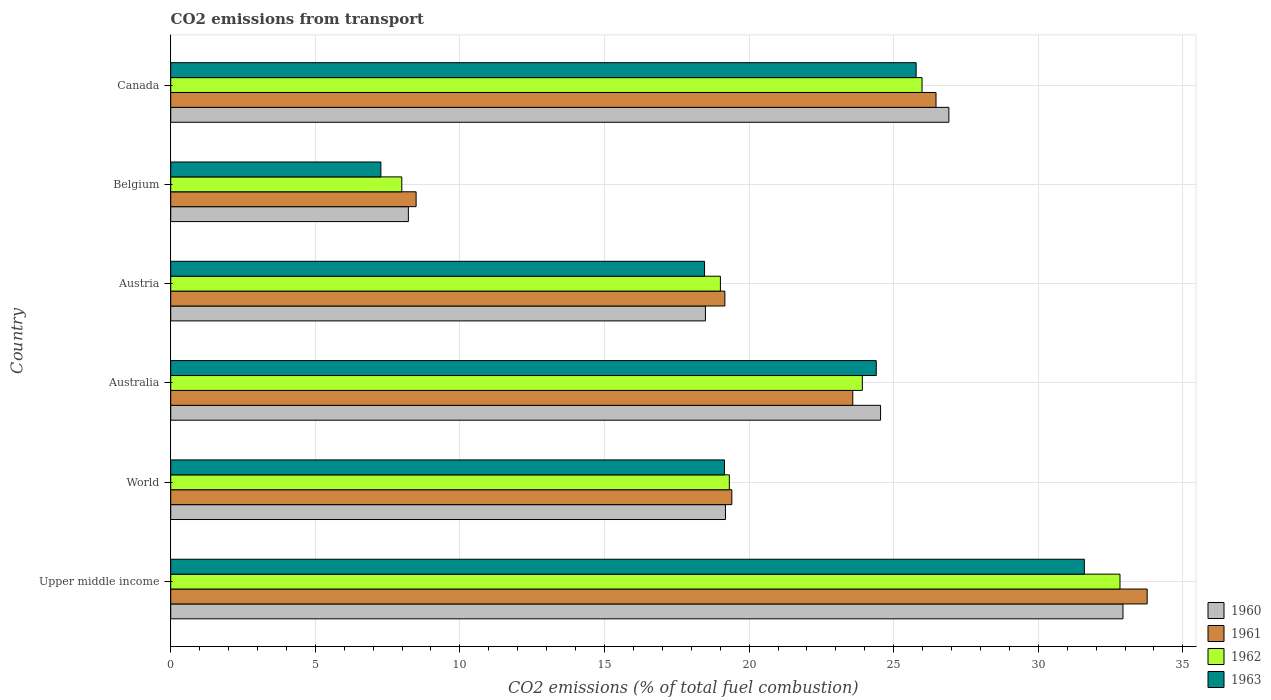Are the number of bars per tick equal to the number of legend labels?
Your response must be concise. Yes. Are the number of bars on each tick of the Y-axis equal?
Ensure brevity in your answer.  Yes. What is the label of the 4th group of bars from the top?
Give a very brief answer. Australia. What is the total CO2 emitted in 1962 in Belgium?
Keep it short and to the point. 7.99. Across all countries, what is the maximum total CO2 emitted in 1963?
Offer a very short reply. 31.59. Across all countries, what is the minimum total CO2 emitted in 1960?
Keep it short and to the point. 8.22. In which country was the total CO2 emitted in 1963 maximum?
Make the answer very short. Upper middle income. In which country was the total CO2 emitted in 1963 minimum?
Keep it short and to the point. Belgium. What is the total total CO2 emitted in 1961 in the graph?
Offer a very short reply. 130.86. What is the difference between the total CO2 emitted in 1962 in Austria and that in Canada?
Provide a short and direct response. -6.97. What is the difference between the total CO2 emitted in 1962 in Australia and the total CO2 emitted in 1961 in World?
Make the answer very short. 4.51. What is the average total CO2 emitted in 1961 per country?
Your answer should be compact. 21.81. What is the difference between the total CO2 emitted in 1963 and total CO2 emitted in 1962 in Austria?
Offer a very short reply. -0.55. In how many countries, is the total CO2 emitted in 1963 greater than 32 ?
Offer a very short reply. 0. What is the ratio of the total CO2 emitted in 1962 in Australia to that in Canada?
Offer a terse response. 0.92. Is the total CO2 emitted in 1962 in Upper middle income less than that in World?
Your response must be concise. No. What is the difference between the highest and the second highest total CO2 emitted in 1962?
Your answer should be very brief. 6.84. What is the difference between the highest and the lowest total CO2 emitted in 1961?
Offer a very short reply. 25.28. In how many countries, is the total CO2 emitted in 1962 greater than the average total CO2 emitted in 1962 taken over all countries?
Provide a short and direct response. 3. What does the 4th bar from the top in Upper middle income represents?
Provide a succinct answer. 1960. What does the 1st bar from the bottom in Australia represents?
Provide a succinct answer. 1960. How many bars are there?
Your answer should be very brief. 24. How many countries are there in the graph?
Ensure brevity in your answer.  6. Does the graph contain grids?
Provide a short and direct response. Yes. Where does the legend appear in the graph?
Your answer should be compact. Bottom right. How many legend labels are there?
Offer a very short reply. 4. What is the title of the graph?
Your response must be concise. CO2 emissions from transport. What is the label or title of the X-axis?
Give a very brief answer. CO2 emissions (% of total fuel combustion). What is the CO2 emissions (% of total fuel combustion) in 1960 in Upper middle income?
Provide a succinct answer. 32.93. What is the CO2 emissions (% of total fuel combustion) of 1961 in Upper middle income?
Your answer should be compact. 33.76. What is the CO2 emissions (% of total fuel combustion) in 1962 in Upper middle income?
Keep it short and to the point. 32.82. What is the CO2 emissions (% of total fuel combustion) of 1963 in Upper middle income?
Keep it short and to the point. 31.59. What is the CO2 emissions (% of total fuel combustion) in 1960 in World?
Your answer should be very brief. 19.18. What is the CO2 emissions (% of total fuel combustion) in 1961 in World?
Keep it short and to the point. 19.4. What is the CO2 emissions (% of total fuel combustion) of 1962 in World?
Ensure brevity in your answer.  19.32. What is the CO2 emissions (% of total fuel combustion) in 1963 in World?
Provide a short and direct response. 19.15. What is the CO2 emissions (% of total fuel combustion) of 1960 in Australia?
Provide a succinct answer. 24.55. What is the CO2 emissions (% of total fuel combustion) in 1961 in Australia?
Provide a short and direct response. 23.59. What is the CO2 emissions (% of total fuel combustion) of 1962 in Australia?
Your response must be concise. 23.92. What is the CO2 emissions (% of total fuel combustion) in 1963 in Australia?
Offer a very short reply. 24.4. What is the CO2 emissions (% of total fuel combustion) of 1960 in Austria?
Your response must be concise. 18.49. What is the CO2 emissions (% of total fuel combustion) in 1961 in Austria?
Your answer should be compact. 19.16. What is the CO2 emissions (% of total fuel combustion) in 1962 in Austria?
Ensure brevity in your answer.  19.01. What is the CO2 emissions (% of total fuel combustion) in 1963 in Austria?
Your answer should be very brief. 18.46. What is the CO2 emissions (% of total fuel combustion) of 1960 in Belgium?
Give a very brief answer. 8.22. What is the CO2 emissions (% of total fuel combustion) of 1961 in Belgium?
Give a very brief answer. 8.49. What is the CO2 emissions (% of total fuel combustion) of 1962 in Belgium?
Your answer should be compact. 7.99. What is the CO2 emissions (% of total fuel combustion) in 1963 in Belgium?
Ensure brevity in your answer.  7.27. What is the CO2 emissions (% of total fuel combustion) of 1960 in Canada?
Make the answer very short. 26.91. What is the CO2 emissions (% of total fuel combustion) in 1961 in Canada?
Your answer should be very brief. 26.46. What is the CO2 emissions (% of total fuel combustion) of 1962 in Canada?
Ensure brevity in your answer.  25.98. What is the CO2 emissions (% of total fuel combustion) in 1963 in Canada?
Provide a succinct answer. 25.78. Across all countries, what is the maximum CO2 emissions (% of total fuel combustion) in 1960?
Give a very brief answer. 32.93. Across all countries, what is the maximum CO2 emissions (% of total fuel combustion) of 1961?
Provide a short and direct response. 33.76. Across all countries, what is the maximum CO2 emissions (% of total fuel combustion) of 1962?
Offer a terse response. 32.82. Across all countries, what is the maximum CO2 emissions (% of total fuel combustion) of 1963?
Make the answer very short. 31.59. Across all countries, what is the minimum CO2 emissions (% of total fuel combustion) of 1960?
Provide a short and direct response. 8.22. Across all countries, what is the minimum CO2 emissions (% of total fuel combustion) in 1961?
Give a very brief answer. 8.49. Across all countries, what is the minimum CO2 emissions (% of total fuel combustion) in 1962?
Ensure brevity in your answer.  7.99. Across all countries, what is the minimum CO2 emissions (% of total fuel combustion) of 1963?
Your response must be concise. 7.27. What is the total CO2 emissions (% of total fuel combustion) in 1960 in the graph?
Keep it short and to the point. 130.27. What is the total CO2 emissions (% of total fuel combustion) of 1961 in the graph?
Keep it short and to the point. 130.86. What is the total CO2 emissions (% of total fuel combustion) of 1962 in the graph?
Ensure brevity in your answer.  129.03. What is the total CO2 emissions (% of total fuel combustion) of 1963 in the graph?
Ensure brevity in your answer.  126.64. What is the difference between the CO2 emissions (% of total fuel combustion) in 1960 in Upper middle income and that in World?
Ensure brevity in your answer.  13.75. What is the difference between the CO2 emissions (% of total fuel combustion) in 1961 in Upper middle income and that in World?
Offer a terse response. 14.36. What is the difference between the CO2 emissions (% of total fuel combustion) in 1962 in Upper middle income and that in World?
Your answer should be compact. 13.51. What is the difference between the CO2 emissions (% of total fuel combustion) in 1963 in Upper middle income and that in World?
Provide a succinct answer. 12.44. What is the difference between the CO2 emissions (% of total fuel combustion) of 1960 in Upper middle income and that in Australia?
Keep it short and to the point. 8.38. What is the difference between the CO2 emissions (% of total fuel combustion) in 1961 in Upper middle income and that in Australia?
Keep it short and to the point. 10.18. What is the difference between the CO2 emissions (% of total fuel combustion) of 1962 in Upper middle income and that in Australia?
Offer a very short reply. 8.91. What is the difference between the CO2 emissions (% of total fuel combustion) of 1963 in Upper middle income and that in Australia?
Provide a succinct answer. 7.2. What is the difference between the CO2 emissions (% of total fuel combustion) of 1960 in Upper middle income and that in Austria?
Your response must be concise. 14.44. What is the difference between the CO2 emissions (% of total fuel combustion) of 1961 in Upper middle income and that in Austria?
Provide a short and direct response. 14.6. What is the difference between the CO2 emissions (% of total fuel combustion) of 1962 in Upper middle income and that in Austria?
Ensure brevity in your answer.  13.82. What is the difference between the CO2 emissions (% of total fuel combustion) in 1963 in Upper middle income and that in Austria?
Provide a short and direct response. 13.13. What is the difference between the CO2 emissions (% of total fuel combustion) in 1960 in Upper middle income and that in Belgium?
Offer a very short reply. 24.71. What is the difference between the CO2 emissions (% of total fuel combustion) of 1961 in Upper middle income and that in Belgium?
Keep it short and to the point. 25.28. What is the difference between the CO2 emissions (% of total fuel combustion) in 1962 in Upper middle income and that in Belgium?
Provide a short and direct response. 24.83. What is the difference between the CO2 emissions (% of total fuel combustion) in 1963 in Upper middle income and that in Belgium?
Provide a short and direct response. 24.33. What is the difference between the CO2 emissions (% of total fuel combustion) in 1960 in Upper middle income and that in Canada?
Keep it short and to the point. 6.02. What is the difference between the CO2 emissions (% of total fuel combustion) in 1961 in Upper middle income and that in Canada?
Offer a very short reply. 7.3. What is the difference between the CO2 emissions (% of total fuel combustion) of 1962 in Upper middle income and that in Canada?
Your response must be concise. 6.84. What is the difference between the CO2 emissions (% of total fuel combustion) of 1963 in Upper middle income and that in Canada?
Provide a short and direct response. 5.82. What is the difference between the CO2 emissions (% of total fuel combustion) of 1960 in World and that in Australia?
Your answer should be very brief. -5.36. What is the difference between the CO2 emissions (% of total fuel combustion) of 1961 in World and that in Australia?
Keep it short and to the point. -4.18. What is the difference between the CO2 emissions (% of total fuel combustion) of 1962 in World and that in Australia?
Offer a terse response. -4.6. What is the difference between the CO2 emissions (% of total fuel combustion) in 1963 in World and that in Australia?
Ensure brevity in your answer.  -5.25. What is the difference between the CO2 emissions (% of total fuel combustion) in 1960 in World and that in Austria?
Your answer should be very brief. 0.69. What is the difference between the CO2 emissions (% of total fuel combustion) of 1961 in World and that in Austria?
Provide a short and direct response. 0.24. What is the difference between the CO2 emissions (% of total fuel combustion) of 1962 in World and that in Austria?
Keep it short and to the point. 0.31. What is the difference between the CO2 emissions (% of total fuel combustion) of 1963 in World and that in Austria?
Offer a terse response. 0.69. What is the difference between the CO2 emissions (% of total fuel combustion) in 1960 in World and that in Belgium?
Your answer should be very brief. 10.96. What is the difference between the CO2 emissions (% of total fuel combustion) in 1961 in World and that in Belgium?
Ensure brevity in your answer.  10.92. What is the difference between the CO2 emissions (% of total fuel combustion) of 1962 in World and that in Belgium?
Give a very brief answer. 11.33. What is the difference between the CO2 emissions (% of total fuel combustion) of 1963 in World and that in Belgium?
Your answer should be very brief. 11.88. What is the difference between the CO2 emissions (% of total fuel combustion) of 1960 in World and that in Canada?
Provide a succinct answer. -7.72. What is the difference between the CO2 emissions (% of total fuel combustion) in 1961 in World and that in Canada?
Make the answer very short. -7.06. What is the difference between the CO2 emissions (% of total fuel combustion) of 1962 in World and that in Canada?
Provide a short and direct response. -6.66. What is the difference between the CO2 emissions (% of total fuel combustion) of 1963 in World and that in Canada?
Ensure brevity in your answer.  -6.63. What is the difference between the CO2 emissions (% of total fuel combustion) in 1960 in Australia and that in Austria?
Give a very brief answer. 6.06. What is the difference between the CO2 emissions (% of total fuel combustion) in 1961 in Australia and that in Austria?
Provide a succinct answer. 4.42. What is the difference between the CO2 emissions (% of total fuel combustion) of 1962 in Australia and that in Austria?
Ensure brevity in your answer.  4.91. What is the difference between the CO2 emissions (% of total fuel combustion) of 1963 in Australia and that in Austria?
Give a very brief answer. 5.94. What is the difference between the CO2 emissions (% of total fuel combustion) in 1960 in Australia and that in Belgium?
Offer a terse response. 16.33. What is the difference between the CO2 emissions (% of total fuel combustion) of 1961 in Australia and that in Belgium?
Your response must be concise. 15.1. What is the difference between the CO2 emissions (% of total fuel combustion) in 1962 in Australia and that in Belgium?
Your response must be concise. 15.93. What is the difference between the CO2 emissions (% of total fuel combustion) in 1963 in Australia and that in Belgium?
Your response must be concise. 17.13. What is the difference between the CO2 emissions (% of total fuel combustion) of 1960 in Australia and that in Canada?
Your answer should be very brief. -2.36. What is the difference between the CO2 emissions (% of total fuel combustion) in 1961 in Australia and that in Canada?
Your answer should be compact. -2.88. What is the difference between the CO2 emissions (% of total fuel combustion) in 1962 in Australia and that in Canada?
Give a very brief answer. -2.06. What is the difference between the CO2 emissions (% of total fuel combustion) of 1963 in Australia and that in Canada?
Your answer should be very brief. -1.38. What is the difference between the CO2 emissions (% of total fuel combustion) in 1960 in Austria and that in Belgium?
Ensure brevity in your answer.  10.27. What is the difference between the CO2 emissions (% of total fuel combustion) in 1961 in Austria and that in Belgium?
Offer a terse response. 10.68. What is the difference between the CO2 emissions (% of total fuel combustion) of 1962 in Austria and that in Belgium?
Your answer should be compact. 11.02. What is the difference between the CO2 emissions (% of total fuel combustion) of 1963 in Austria and that in Belgium?
Make the answer very short. 11.19. What is the difference between the CO2 emissions (% of total fuel combustion) of 1960 in Austria and that in Canada?
Your answer should be compact. -8.42. What is the difference between the CO2 emissions (% of total fuel combustion) in 1961 in Austria and that in Canada?
Offer a very short reply. -7.3. What is the difference between the CO2 emissions (% of total fuel combustion) of 1962 in Austria and that in Canada?
Offer a terse response. -6.97. What is the difference between the CO2 emissions (% of total fuel combustion) in 1963 in Austria and that in Canada?
Keep it short and to the point. -7.32. What is the difference between the CO2 emissions (% of total fuel combustion) in 1960 in Belgium and that in Canada?
Provide a short and direct response. -18.69. What is the difference between the CO2 emissions (% of total fuel combustion) in 1961 in Belgium and that in Canada?
Your answer should be compact. -17.98. What is the difference between the CO2 emissions (% of total fuel combustion) in 1962 in Belgium and that in Canada?
Your response must be concise. -17.99. What is the difference between the CO2 emissions (% of total fuel combustion) in 1963 in Belgium and that in Canada?
Provide a succinct answer. -18.51. What is the difference between the CO2 emissions (% of total fuel combustion) of 1960 in Upper middle income and the CO2 emissions (% of total fuel combustion) of 1961 in World?
Make the answer very short. 13.53. What is the difference between the CO2 emissions (% of total fuel combustion) of 1960 in Upper middle income and the CO2 emissions (% of total fuel combustion) of 1962 in World?
Provide a succinct answer. 13.61. What is the difference between the CO2 emissions (% of total fuel combustion) in 1960 in Upper middle income and the CO2 emissions (% of total fuel combustion) in 1963 in World?
Offer a very short reply. 13.78. What is the difference between the CO2 emissions (% of total fuel combustion) of 1961 in Upper middle income and the CO2 emissions (% of total fuel combustion) of 1962 in World?
Offer a very short reply. 14.45. What is the difference between the CO2 emissions (% of total fuel combustion) of 1961 in Upper middle income and the CO2 emissions (% of total fuel combustion) of 1963 in World?
Keep it short and to the point. 14.62. What is the difference between the CO2 emissions (% of total fuel combustion) in 1962 in Upper middle income and the CO2 emissions (% of total fuel combustion) in 1963 in World?
Provide a succinct answer. 13.68. What is the difference between the CO2 emissions (% of total fuel combustion) in 1960 in Upper middle income and the CO2 emissions (% of total fuel combustion) in 1961 in Australia?
Your answer should be compact. 9.34. What is the difference between the CO2 emissions (% of total fuel combustion) of 1960 in Upper middle income and the CO2 emissions (% of total fuel combustion) of 1962 in Australia?
Provide a short and direct response. 9.01. What is the difference between the CO2 emissions (% of total fuel combustion) of 1960 in Upper middle income and the CO2 emissions (% of total fuel combustion) of 1963 in Australia?
Ensure brevity in your answer.  8.53. What is the difference between the CO2 emissions (% of total fuel combustion) of 1961 in Upper middle income and the CO2 emissions (% of total fuel combustion) of 1962 in Australia?
Ensure brevity in your answer.  9.85. What is the difference between the CO2 emissions (% of total fuel combustion) in 1961 in Upper middle income and the CO2 emissions (% of total fuel combustion) in 1963 in Australia?
Ensure brevity in your answer.  9.37. What is the difference between the CO2 emissions (% of total fuel combustion) in 1962 in Upper middle income and the CO2 emissions (% of total fuel combustion) in 1963 in Australia?
Your response must be concise. 8.43. What is the difference between the CO2 emissions (% of total fuel combustion) of 1960 in Upper middle income and the CO2 emissions (% of total fuel combustion) of 1961 in Austria?
Provide a succinct answer. 13.77. What is the difference between the CO2 emissions (% of total fuel combustion) of 1960 in Upper middle income and the CO2 emissions (% of total fuel combustion) of 1962 in Austria?
Give a very brief answer. 13.92. What is the difference between the CO2 emissions (% of total fuel combustion) in 1960 in Upper middle income and the CO2 emissions (% of total fuel combustion) in 1963 in Austria?
Make the answer very short. 14.47. What is the difference between the CO2 emissions (% of total fuel combustion) in 1961 in Upper middle income and the CO2 emissions (% of total fuel combustion) in 1962 in Austria?
Give a very brief answer. 14.76. What is the difference between the CO2 emissions (% of total fuel combustion) in 1961 in Upper middle income and the CO2 emissions (% of total fuel combustion) in 1963 in Austria?
Offer a very short reply. 15.3. What is the difference between the CO2 emissions (% of total fuel combustion) of 1962 in Upper middle income and the CO2 emissions (% of total fuel combustion) of 1963 in Austria?
Your response must be concise. 14.36. What is the difference between the CO2 emissions (% of total fuel combustion) in 1960 in Upper middle income and the CO2 emissions (% of total fuel combustion) in 1961 in Belgium?
Provide a short and direct response. 24.44. What is the difference between the CO2 emissions (% of total fuel combustion) in 1960 in Upper middle income and the CO2 emissions (% of total fuel combustion) in 1962 in Belgium?
Your answer should be very brief. 24.94. What is the difference between the CO2 emissions (% of total fuel combustion) in 1960 in Upper middle income and the CO2 emissions (% of total fuel combustion) in 1963 in Belgium?
Make the answer very short. 25.66. What is the difference between the CO2 emissions (% of total fuel combustion) of 1961 in Upper middle income and the CO2 emissions (% of total fuel combustion) of 1962 in Belgium?
Ensure brevity in your answer.  25.77. What is the difference between the CO2 emissions (% of total fuel combustion) of 1961 in Upper middle income and the CO2 emissions (% of total fuel combustion) of 1963 in Belgium?
Provide a succinct answer. 26.5. What is the difference between the CO2 emissions (% of total fuel combustion) in 1962 in Upper middle income and the CO2 emissions (% of total fuel combustion) in 1963 in Belgium?
Make the answer very short. 25.56. What is the difference between the CO2 emissions (% of total fuel combustion) in 1960 in Upper middle income and the CO2 emissions (% of total fuel combustion) in 1961 in Canada?
Give a very brief answer. 6.46. What is the difference between the CO2 emissions (% of total fuel combustion) of 1960 in Upper middle income and the CO2 emissions (% of total fuel combustion) of 1962 in Canada?
Your answer should be compact. 6.95. What is the difference between the CO2 emissions (% of total fuel combustion) in 1960 in Upper middle income and the CO2 emissions (% of total fuel combustion) in 1963 in Canada?
Make the answer very short. 7.15. What is the difference between the CO2 emissions (% of total fuel combustion) of 1961 in Upper middle income and the CO2 emissions (% of total fuel combustion) of 1962 in Canada?
Provide a short and direct response. 7.78. What is the difference between the CO2 emissions (% of total fuel combustion) of 1961 in Upper middle income and the CO2 emissions (% of total fuel combustion) of 1963 in Canada?
Provide a succinct answer. 7.99. What is the difference between the CO2 emissions (% of total fuel combustion) of 1962 in Upper middle income and the CO2 emissions (% of total fuel combustion) of 1963 in Canada?
Your response must be concise. 7.05. What is the difference between the CO2 emissions (% of total fuel combustion) in 1960 in World and the CO2 emissions (% of total fuel combustion) in 1961 in Australia?
Ensure brevity in your answer.  -4.4. What is the difference between the CO2 emissions (% of total fuel combustion) in 1960 in World and the CO2 emissions (% of total fuel combustion) in 1962 in Australia?
Your answer should be compact. -4.73. What is the difference between the CO2 emissions (% of total fuel combustion) in 1960 in World and the CO2 emissions (% of total fuel combustion) in 1963 in Australia?
Provide a succinct answer. -5.21. What is the difference between the CO2 emissions (% of total fuel combustion) in 1961 in World and the CO2 emissions (% of total fuel combustion) in 1962 in Australia?
Keep it short and to the point. -4.51. What is the difference between the CO2 emissions (% of total fuel combustion) in 1961 in World and the CO2 emissions (% of total fuel combustion) in 1963 in Australia?
Your response must be concise. -4.99. What is the difference between the CO2 emissions (% of total fuel combustion) in 1962 in World and the CO2 emissions (% of total fuel combustion) in 1963 in Australia?
Offer a very short reply. -5.08. What is the difference between the CO2 emissions (% of total fuel combustion) of 1960 in World and the CO2 emissions (% of total fuel combustion) of 1961 in Austria?
Your response must be concise. 0.02. What is the difference between the CO2 emissions (% of total fuel combustion) of 1960 in World and the CO2 emissions (% of total fuel combustion) of 1962 in Austria?
Your answer should be compact. 0.18. What is the difference between the CO2 emissions (% of total fuel combustion) in 1960 in World and the CO2 emissions (% of total fuel combustion) in 1963 in Austria?
Make the answer very short. 0.72. What is the difference between the CO2 emissions (% of total fuel combustion) in 1961 in World and the CO2 emissions (% of total fuel combustion) in 1962 in Austria?
Make the answer very short. 0.4. What is the difference between the CO2 emissions (% of total fuel combustion) of 1961 in World and the CO2 emissions (% of total fuel combustion) of 1963 in Austria?
Your answer should be compact. 0.94. What is the difference between the CO2 emissions (% of total fuel combustion) of 1962 in World and the CO2 emissions (% of total fuel combustion) of 1963 in Austria?
Offer a terse response. 0.86. What is the difference between the CO2 emissions (% of total fuel combustion) in 1960 in World and the CO2 emissions (% of total fuel combustion) in 1961 in Belgium?
Your answer should be very brief. 10.7. What is the difference between the CO2 emissions (% of total fuel combustion) of 1960 in World and the CO2 emissions (% of total fuel combustion) of 1962 in Belgium?
Give a very brief answer. 11.19. What is the difference between the CO2 emissions (% of total fuel combustion) of 1960 in World and the CO2 emissions (% of total fuel combustion) of 1963 in Belgium?
Your response must be concise. 11.92. What is the difference between the CO2 emissions (% of total fuel combustion) of 1961 in World and the CO2 emissions (% of total fuel combustion) of 1962 in Belgium?
Make the answer very short. 11.41. What is the difference between the CO2 emissions (% of total fuel combustion) in 1961 in World and the CO2 emissions (% of total fuel combustion) in 1963 in Belgium?
Offer a terse response. 12.14. What is the difference between the CO2 emissions (% of total fuel combustion) of 1962 in World and the CO2 emissions (% of total fuel combustion) of 1963 in Belgium?
Keep it short and to the point. 12.05. What is the difference between the CO2 emissions (% of total fuel combustion) of 1960 in World and the CO2 emissions (% of total fuel combustion) of 1961 in Canada?
Keep it short and to the point. -7.28. What is the difference between the CO2 emissions (% of total fuel combustion) of 1960 in World and the CO2 emissions (% of total fuel combustion) of 1962 in Canada?
Ensure brevity in your answer.  -6.8. What is the difference between the CO2 emissions (% of total fuel combustion) of 1960 in World and the CO2 emissions (% of total fuel combustion) of 1963 in Canada?
Keep it short and to the point. -6.59. What is the difference between the CO2 emissions (% of total fuel combustion) in 1961 in World and the CO2 emissions (% of total fuel combustion) in 1962 in Canada?
Give a very brief answer. -6.58. What is the difference between the CO2 emissions (% of total fuel combustion) of 1961 in World and the CO2 emissions (% of total fuel combustion) of 1963 in Canada?
Offer a terse response. -6.37. What is the difference between the CO2 emissions (% of total fuel combustion) in 1962 in World and the CO2 emissions (% of total fuel combustion) in 1963 in Canada?
Provide a succinct answer. -6.46. What is the difference between the CO2 emissions (% of total fuel combustion) of 1960 in Australia and the CO2 emissions (% of total fuel combustion) of 1961 in Austria?
Give a very brief answer. 5.38. What is the difference between the CO2 emissions (% of total fuel combustion) of 1960 in Australia and the CO2 emissions (% of total fuel combustion) of 1962 in Austria?
Keep it short and to the point. 5.54. What is the difference between the CO2 emissions (% of total fuel combustion) in 1960 in Australia and the CO2 emissions (% of total fuel combustion) in 1963 in Austria?
Keep it short and to the point. 6.09. What is the difference between the CO2 emissions (% of total fuel combustion) of 1961 in Australia and the CO2 emissions (% of total fuel combustion) of 1962 in Austria?
Provide a succinct answer. 4.58. What is the difference between the CO2 emissions (% of total fuel combustion) in 1961 in Australia and the CO2 emissions (% of total fuel combustion) in 1963 in Austria?
Keep it short and to the point. 5.13. What is the difference between the CO2 emissions (% of total fuel combustion) of 1962 in Australia and the CO2 emissions (% of total fuel combustion) of 1963 in Austria?
Keep it short and to the point. 5.46. What is the difference between the CO2 emissions (% of total fuel combustion) of 1960 in Australia and the CO2 emissions (% of total fuel combustion) of 1961 in Belgium?
Provide a short and direct response. 16.06. What is the difference between the CO2 emissions (% of total fuel combustion) in 1960 in Australia and the CO2 emissions (% of total fuel combustion) in 1962 in Belgium?
Your answer should be compact. 16.56. What is the difference between the CO2 emissions (% of total fuel combustion) in 1960 in Australia and the CO2 emissions (% of total fuel combustion) in 1963 in Belgium?
Keep it short and to the point. 17.28. What is the difference between the CO2 emissions (% of total fuel combustion) of 1961 in Australia and the CO2 emissions (% of total fuel combustion) of 1962 in Belgium?
Keep it short and to the point. 15.59. What is the difference between the CO2 emissions (% of total fuel combustion) of 1961 in Australia and the CO2 emissions (% of total fuel combustion) of 1963 in Belgium?
Offer a terse response. 16.32. What is the difference between the CO2 emissions (% of total fuel combustion) of 1962 in Australia and the CO2 emissions (% of total fuel combustion) of 1963 in Belgium?
Ensure brevity in your answer.  16.65. What is the difference between the CO2 emissions (% of total fuel combustion) in 1960 in Australia and the CO2 emissions (% of total fuel combustion) in 1961 in Canada?
Offer a terse response. -1.92. What is the difference between the CO2 emissions (% of total fuel combustion) in 1960 in Australia and the CO2 emissions (% of total fuel combustion) in 1962 in Canada?
Provide a short and direct response. -1.43. What is the difference between the CO2 emissions (% of total fuel combustion) of 1960 in Australia and the CO2 emissions (% of total fuel combustion) of 1963 in Canada?
Offer a terse response. -1.23. What is the difference between the CO2 emissions (% of total fuel combustion) in 1961 in Australia and the CO2 emissions (% of total fuel combustion) in 1962 in Canada?
Provide a succinct answer. -2.4. What is the difference between the CO2 emissions (% of total fuel combustion) of 1961 in Australia and the CO2 emissions (% of total fuel combustion) of 1963 in Canada?
Keep it short and to the point. -2.19. What is the difference between the CO2 emissions (% of total fuel combustion) of 1962 in Australia and the CO2 emissions (% of total fuel combustion) of 1963 in Canada?
Provide a short and direct response. -1.86. What is the difference between the CO2 emissions (% of total fuel combustion) in 1960 in Austria and the CO2 emissions (% of total fuel combustion) in 1961 in Belgium?
Provide a succinct answer. 10. What is the difference between the CO2 emissions (% of total fuel combustion) in 1960 in Austria and the CO2 emissions (% of total fuel combustion) in 1962 in Belgium?
Keep it short and to the point. 10.5. What is the difference between the CO2 emissions (% of total fuel combustion) of 1960 in Austria and the CO2 emissions (% of total fuel combustion) of 1963 in Belgium?
Your answer should be very brief. 11.22. What is the difference between the CO2 emissions (% of total fuel combustion) of 1961 in Austria and the CO2 emissions (% of total fuel combustion) of 1962 in Belgium?
Ensure brevity in your answer.  11.17. What is the difference between the CO2 emissions (% of total fuel combustion) of 1961 in Austria and the CO2 emissions (% of total fuel combustion) of 1963 in Belgium?
Your answer should be compact. 11.9. What is the difference between the CO2 emissions (% of total fuel combustion) in 1962 in Austria and the CO2 emissions (% of total fuel combustion) in 1963 in Belgium?
Give a very brief answer. 11.74. What is the difference between the CO2 emissions (% of total fuel combustion) in 1960 in Austria and the CO2 emissions (% of total fuel combustion) in 1961 in Canada?
Keep it short and to the point. -7.97. What is the difference between the CO2 emissions (% of total fuel combustion) in 1960 in Austria and the CO2 emissions (% of total fuel combustion) in 1962 in Canada?
Offer a very short reply. -7.49. What is the difference between the CO2 emissions (% of total fuel combustion) of 1960 in Austria and the CO2 emissions (% of total fuel combustion) of 1963 in Canada?
Provide a short and direct response. -7.29. What is the difference between the CO2 emissions (% of total fuel combustion) of 1961 in Austria and the CO2 emissions (% of total fuel combustion) of 1962 in Canada?
Provide a short and direct response. -6.82. What is the difference between the CO2 emissions (% of total fuel combustion) in 1961 in Austria and the CO2 emissions (% of total fuel combustion) in 1963 in Canada?
Ensure brevity in your answer.  -6.61. What is the difference between the CO2 emissions (% of total fuel combustion) of 1962 in Austria and the CO2 emissions (% of total fuel combustion) of 1963 in Canada?
Offer a very short reply. -6.77. What is the difference between the CO2 emissions (% of total fuel combustion) in 1960 in Belgium and the CO2 emissions (% of total fuel combustion) in 1961 in Canada?
Offer a very short reply. -18.25. What is the difference between the CO2 emissions (% of total fuel combustion) in 1960 in Belgium and the CO2 emissions (% of total fuel combustion) in 1962 in Canada?
Make the answer very short. -17.76. What is the difference between the CO2 emissions (% of total fuel combustion) of 1960 in Belgium and the CO2 emissions (% of total fuel combustion) of 1963 in Canada?
Keep it short and to the point. -17.56. What is the difference between the CO2 emissions (% of total fuel combustion) of 1961 in Belgium and the CO2 emissions (% of total fuel combustion) of 1962 in Canada?
Make the answer very short. -17.5. What is the difference between the CO2 emissions (% of total fuel combustion) of 1961 in Belgium and the CO2 emissions (% of total fuel combustion) of 1963 in Canada?
Ensure brevity in your answer.  -17.29. What is the difference between the CO2 emissions (% of total fuel combustion) in 1962 in Belgium and the CO2 emissions (% of total fuel combustion) in 1963 in Canada?
Offer a very short reply. -17.79. What is the average CO2 emissions (% of total fuel combustion) of 1960 per country?
Your answer should be very brief. 21.71. What is the average CO2 emissions (% of total fuel combustion) in 1961 per country?
Offer a terse response. 21.81. What is the average CO2 emissions (% of total fuel combustion) of 1962 per country?
Your answer should be compact. 21.51. What is the average CO2 emissions (% of total fuel combustion) in 1963 per country?
Ensure brevity in your answer.  21.11. What is the difference between the CO2 emissions (% of total fuel combustion) of 1960 and CO2 emissions (% of total fuel combustion) of 1961 in Upper middle income?
Give a very brief answer. -0.84. What is the difference between the CO2 emissions (% of total fuel combustion) in 1960 and CO2 emissions (% of total fuel combustion) in 1962 in Upper middle income?
Keep it short and to the point. 0.1. What is the difference between the CO2 emissions (% of total fuel combustion) in 1960 and CO2 emissions (% of total fuel combustion) in 1963 in Upper middle income?
Your answer should be compact. 1.34. What is the difference between the CO2 emissions (% of total fuel combustion) of 1961 and CO2 emissions (% of total fuel combustion) of 1962 in Upper middle income?
Keep it short and to the point. 0.94. What is the difference between the CO2 emissions (% of total fuel combustion) in 1961 and CO2 emissions (% of total fuel combustion) in 1963 in Upper middle income?
Make the answer very short. 2.17. What is the difference between the CO2 emissions (% of total fuel combustion) of 1962 and CO2 emissions (% of total fuel combustion) of 1963 in Upper middle income?
Make the answer very short. 1.23. What is the difference between the CO2 emissions (% of total fuel combustion) of 1960 and CO2 emissions (% of total fuel combustion) of 1961 in World?
Make the answer very short. -0.22. What is the difference between the CO2 emissions (% of total fuel combustion) of 1960 and CO2 emissions (% of total fuel combustion) of 1962 in World?
Provide a succinct answer. -0.13. What is the difference between the CO2 emissions (% of total fuel combustion) of 1960 and CO2 emissions (% of total fuel combustion) of 1963 in World?
Your answer should be compact. 0.03. What is the difference between the CO2 emissions (% of total fuel combustion) of 1961 and CO2 emissions (% of total fuel combustion) of 1962 in World?
Give a very brief answer. 0.09. What is the difference between the CO2 emissions (% of total fuel combustion) of 1961 and CO2 emissions (% of total fuel combustion) of 1963 in World?
Make the answer very short. 0.25. What is the difference between the CO2 emissions (% of total fuel combustion) of 1962 and CO2 emissions (% of total fuel combustion) of 1963 in World?
Your answer should be very brief. 0.17. What is the difference between the CO2 emissions (% of total fuel combustion) in 1960 and CO2 emissions (% of total fuel combustion) in 1961 in Australia?
Make the answer very short. 0.96. What is the difference between the CO2 emissions (% of total fuel combustion) in 1960 and CO2 emissions (% of total fuel combustion) in 1962 in Australia?
Your answer should be compact. 0.63. What is the difference between the CO2 emissions (% of total fuel combustion) of 1960 and CO2 emissions (% of total fuel combustion) of 1963 in Australia?
Ensure brevity in your answer.  0.15. What is the difference between the CO2 emissions (% of total fuel combustion) of 1961 and CO2 emissions (% of total fuel combustion) of 1962 in Australia?
Give a very brief answer. -0.33. What is the difference between the CO2 emissions (% of total fuel combustion) of 1961 and CO2 emissions (% of total fuel combustion) of 1963 in Australia?
Your response must be concise. -0.81. What is the difference between the CO2 emissions (% of total fuel combustion) of 1962 and CO2 emissions (% of total fuel combustion) of 1963 in Australia?
Make the answer very short. -0.48. What is the difference between the CO2 emissions (% of total fuel combustion) of 1960 and CO2 emissions (% of total fuel combustion) of 1961 in Austria?
Your response must be concise. -0.67. What is the difference between the CO2 emissions (% of total fuel combustion) of 1960 and CO2 emissions (% of total fuel combustion) of 1962 in Austria?
Ensure brevity in your answer.  -0.52. What is the difference between the CO2 emissions (% of total fuel combustion) of 1960 and CO2 emissions (% of total fuel combustion) of 1963 in Austria?
Your answer should be very brief. 0.03. What is the difference between the CO2 emissions (% of total fuel combustion) in 1961 and CO2 emissions (% of total fuel combustion) in 1962 in Austria?
Your answer should be compact. 0.15. What is the difference between the CO2 emissions (% of total fuel combustion) of 1961 and CO2 emissions (% of total fuel combustion) of 1963 in Austria?
Offer a very short reply. 0.7. What is the difference between the CO2 emissions (% of total fuel combustion) of 1962 and CO2 emissions (% of total fuel combustion) of 1963 in Austria?
Keep it short and to the point. 0.55. What is the difference between the CO2 emissions (% of total fuel combustion) of 1960 and CO2 emissions (% of total fuel combustion) of 1961 in Belgium?
Make the answer very short. -0.27. What is the difference between the CO2 emissions (% of total fuel combustion) of 1960 and CO2 emissions (% of total fuel combustion) of 1962 in Belgium?
Keep it short and to the point. 0.23. What is the difference between the CO2 emissions (% of total fuel combustion) in 1960 and CO2 emissions (% of total fuel combustion) in 1963 in Belgium?
Provide a succinct answer. 0.95. What is the difference between the CO2 emissions (% of total fuel combustion) in 1961 and CO2 emissions (% of total fuel combustion) in 1962 in Belgium?
Provide a short and direct response. 0.49. What is the difference between the CO2 emissions (% of total fuel combustion) in 1961 and CO2 emissions (% of total fuel combustion) in 1963 in Belgium?
Your response must be concise. 1.22. What is the difference between the CO2 emissions (% of total fuel combustion) in 1962 and CO2 emissions (% of total fuel combustion) in 1963 in Belgium?
Ensure brevity in your answer.  0.72. What is the difference between the CO2 emissions (% of total fuel combustion) in 1960 and CO2 emissions (% of total fuel combustion) in 1961 in Canada?
Provide a succinct answer. 0.44. What is the difference between the CO2 emissions (% of total fuel combustion) of 1960 and CO2 emissions (% of total fuel combustion) of 1962 in Canada?
Keep it short and to the point. 0.93. What is the difference between the CO2 emissions (% of total fuel combustion) of 1960 and CO2 emissions (% of total fuel combustion) of 1963 in Canada?
Your answer should be compact. 1.13. What is the difference between the CO2 emissions (% of total fuel combustion) in 1961 and CO2 emissions (% of total fuel combustion) in 1962 in Canada?
Ensure brevity in your answer.  0.48. What is the difference between the CO2 emissions (% of total fuel combustion) of 1961 and CO2 emissions (% of total fuel combustion) of 1963 in Canada?
Offer a very short reply. 0.69. What is the difference between the CO2 emissions (% of total fuel combustion) in 1962 and CO2 emissions (% of total fuel combustion) in 1963 in Canada?
Make the answer very short. 0.2. What is the ratio of the CO2 emissions (% of total fuel combustion) in 1960 in Upper middle income to that in World?
Offer a very short reply. 1.72. What is the ratio of the CO2 emissions (% of total fuel combustion) in 1961 in Upper middle income to that in World?
Give a very brief answer. 1.74. What is the ratio of the CO2 emissions (% of total fuel combustion) in 1962 in Upper middle income to that in World?
Your response must be concise. 1.7. What is the ratio of the CO2 emissions (% of total fuel combustion) of 1963 in Upper middle income to that in World?
Provide a short and direct response. 1.65. What is the ratio of the CO2 emissions (% of total fuel combustion) in 1960 in Upper middle income to that in Australia?
Offer a very short reply. 1.34. What is the ratio of the CO2 emissions (% of total fuel combustion) in 1961 in Upper middle income to that in Australia?
Keep it short and to the point. 1.43. What is the ratio of the CO2 emissions (% of total fuel combustion) in 1962 in Upper middle income to that in Australia?
Your answer should be very brief. 1.37. What is the ratio of the CO2 emissions (% of total fuel combustion) of 1963 in Upper middle income to that in Australia?
Your answer should be very brief. 1.29. What is the ratio of the CO2 emissions (% of total fuel combustion) in 1960 in Upper middle income to that in Austria?
Make the answer very short. 1.78. What is the ratio of the CO2 emissions (% of total fuel combustion) of 1961 in Upper middle income to that in Austria?
Offer a very short reply. 1.76. What is the ratio of the CO2 emissions (% of total fuel combustion) in 1962 in Upper middle income to that in Austria?
Your answer should be compact. 1.73. What is the ratio of the CO2 emissions (% of total fuel combustion) of 1963 in Upper middle income to that in Austria?
Offer a terse response. 1.71. What is the ratio of the CO2 emissions (% of total fuel combustion) of 1960 in Upper middle income to that in Belgium?
Your answer should be very brief. 4.01. What is the ratio of the CO2 emissions (% of total fuel combustion) of 1961 in Upper middle income to that in Belgium?
Offer a terse response. 3.98. What is the ratio of the CO2 emissions (% of total fuel combustion) in 1962 in Upper middle income to that in Belgium?
Give a very brief answer. 4.11. What is the ratio of the CO2 emissions (% of total fuel combustion) in 1963 in Upper middle income to that in Belgium?
Your answer should be very brief. 4.35. What is the ratio of the CO2 emissions (% of total fuel combustion) of 1960 in Upper middle income to that in Canada?
Offer a terse response. 1.22. What is the ratio of the CO2 emissions (% of total fuel combustion) of 1961 in Upper middle income to that in Canada?
Give a very brief answer. 1.28. What is the ratio of the CO2 emissions (% of total fuel combustion) in 1962 in Upper middle income to that in Canada?
Your answer should be very brief. 1.26. What is the ratio of the CO2 emissions (% of total fuel combustion) in 1963 in Upper middle income to that in Canada?
Provide a short and direct response. 1.23. What is the ratio of the CO2 emissions (% of total fuel combustion) in 1960 in World to that in Australia?
Provide a short and direct response. 0.78. What is the ratio of the CO2 emissions (% of total fuel combustion) in 1961 in World to that in Australia?
Offer a very short reply. 0.82. What is the ratio of the CO2 emissions (% of total fuel combustion) of 1962 in World to that in Australia?
Give a very brief answer. 0.81. What is the ratio of the CO2 emissions (% of total fuel combustion) in 1963 in World to that in Australia?
Provide a short and direct response. 0.78. What is the ratio of the CO2 emissions (% of total fuel combustion) in 1960 in World to that in Austria?
Your answer should be very brief. 1.04. What is the ratio of the CO2 emissions (% of total fuel combustion) of 1961 in World to that in Austria?
Your answer should be compact. 1.01. What is the ratio of the CO2 emissions (% of total fuel combustion) of 1962 in World to that in Austria?
Your answer should be compact. 1.02. What is the ratio of the CO2 emissions (% of total fuel combustion) in 1963 in World to that in Austria?
Offer a very short reply. 1.04. What is the ratio of the CO2 emissions (% of total fuel combustion) of 1960 in World to that in Belgium?
Your response must be concise. 2.33. What is the ratio of the CO2 emissions (% of total fuel combustion) of 1961 in World to that in Belgium?
Your answer should be compact. 2.29. What is the ratio of the CO2 emissions (% of total fuel combustion) of 1962 in World to that in Belgium?
Make the answer very short. 2.42. What is the ratio of the CO2 emissions (% of total fuel combustion) in 1963 in World to that in Belgium?
Provide a succinct answer. 2.64. What is the ratio of the CO2 emissions (% of total fuel combustion) in 1960 in World to that in Canada?
Your response must be concise. 0.71. What is the ratio of the CO2 emissions (% of total fuel combustion) of 1961 in World to that in Canada?
Ensure brevity in your answer.  0.73. What is the ratio of the CO2 emissions (% of total fuel combustion) in 1962 in World to that in Canada?
Offer a terse response. 0.74. What is the ratio of the CO2 emissions (% of total fuel combustion) in 1963 in World to that in Canada?
Provide a succinct answer. 0.74. What is the ratio of the CO2 emissions (% of total fuel combustion) in 1960 in Australia to that in Austria?
Your answer should be very brief. 1.33. What is the ratio of the CO2 emissions (% of total fuel combustion) of 1961 in Australia to that in Austria?
Make the answer very short. 1.23. What is the ratio of the CO2 emissions (% of total fuel combustion) of 1962 in Australia to that in Austria?
Offer a terse response. 1.26. What is the ratio of the CO2 emissions (% of total fuel combustion) in 1963 in Australia to that in Austria?
Your answer should be compact. 1.32. What is the ratio of the CO2 emissions (% of total fuel combustion) in 1960 in Australia to that in Belgium?
Your answer should be very brief. 2.99. What is the ratio of the CO2 emissions (% of total fuel combustion) in 1961 in Australia to that in Belgium?
Provide a short and direct response. 2.78. What is the ratio of the CO2 emissions (% of total fuel combustion) in 1962 in Australia to that in Belgium?
Your response must be concise. 2.99. What is the ratio of the CO2 emissions (% of total fuel combustion) in 1963 in Australia to that in Belgium?
Ensure brevity in your answer.  3.36. What is the ratio of the CO2 emissions (% of total fuel combustion) of 1960 in Australia to that in Canada?
Your response must be concise. 0.91. What is the ratio of the CO2 emissions (% of total fuel combustion) in 1961 in Australia to that in Canada?
Your answer should be very brief. 0.89. What is the ratio of the CO2 emissions (% of total fuel combustion) in 1962 in Australia to that in Canada?
Ensure brevity in your answer.  0.92. What is the ratio of the CO2 emissions (% of total fuel combustion) in 1963 in Australia to that in Canada?
Provide a short and direct response. 0.95. What is the ratio of the CO2 emissions (% of total fuel combustion) of 1960 in Austria to that in Belgium?
Your answer should be compact. 2.25. What is the ratio of the CO2 emissions (% of total fuel combustion) of 1961 in Austria to that in Belgium?
Your response must be concise. 2.26. What is the ratio of the CO2 emissions (% of total fuel combustion) in 1962 in Austria to that in Belgium?
Your answer should be very brief. 2.38. What is the ratio of the CO2 emissions (% of total fuel combustion) in 1963 in Austria to that in Belgium?
Offer a terse response. 2.54. What is the ratio of the CO2 emissions (% of total fuel combustion) in 1960 in Austria to that in Canada?
Offer a terse response. 0.69. What is the ratio of the CO2 emissions (% of total fuel combustion) of 1961 in Austria to that in Canada?
Your answer should be very brief. 0.72. What is the ratio of the CO2 emissions (% of total fuel combustion) in 1962 in Austria to that in Canada?
Your answer should be compact. 0.73. What is the ratio of the CO2 emissions (% of total fuel combustion) of 1963 in Austria to that in Canada?
Give a very brief answer. 0.72. What is the ratio of the CO2 emissions (% of total fuel combustion) in 1960 in Belgium to that in Canada?
Provide a short and direct response. 0.31. What is the ratio of the CO2 emissions (% of total fuel combustion) in 1961 in Belgium to that in Canada?
Give a very brief answer. 0.32. What is the ratio of the CO2 emissions (% of total fuel combustion) in 1962 in Belgium to that in Canada?
Offer a terse response. 0.31. What is the ratio of the CO2 emissions (% of total fuel combustion) in 1963 in Belgium to that in Canada?
Your response must be concise. 0.28. What is the difference between the highest and the second highest CO2 emissions (% of total fuel combustion) in 1960?
Offer a very short reply. 6.02. What is the difference between the highest and the second highest CO2 emissions (% of total fuel combustion) of 1961?
Your answer should be very brief. 7.3. What is the difference between the highest and the second highest CO2 emissions (% of total fuel combustion) of 1962?
Provide a succinct answer. 6.84. What is the difference between the highest and the second highest CO2 emissions (% of total fuel combustion) of 1963?
Provide a succinct answer. 5.82. What is the difference between the highest and the lowest CO2 emissions (% of total fuel combustion) in 1960?
Keep it short and to the point. 24.71. What is the difference between the highest and the lowest CO2 emissions (% of total fuel combustion) of 1961?
Provide a succinct answer. 25.28. What is the difference between the highest and the lowest CO2 emissions (% of total fuel combustion) of 1962?
Your response must be concise. 24.83. What is the difference between the highest and the lowest CO2 emissions (% of total fuel combustion) in 1963?
Your answer should be very brief. 24.33. 